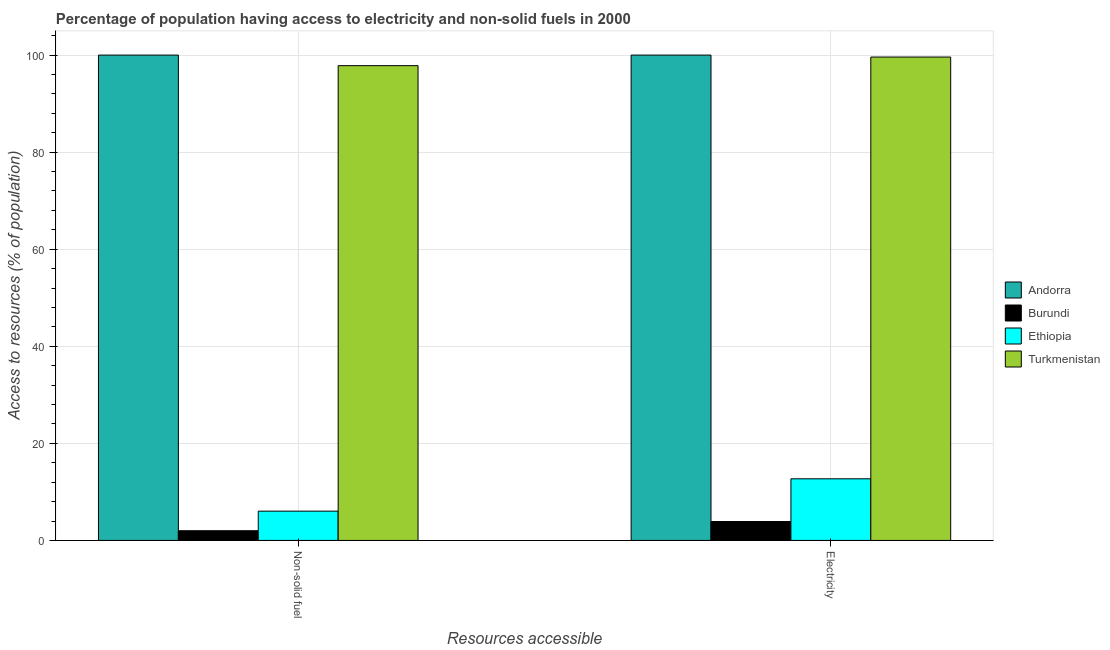Are the number of bars per tick equal to the number of legend labels?
Your response must be concise. Yes. How many bars are there on the 1st tick from the left?
Provide a succinct answer. 4. How many bars are there on the 2nd tick from the right?
Provide a short and direct response. 4. What is the label of the 1st group of bars from the left?
Your answer should be compact. Non-solid fuel. What is the percentage of population having access to electricity in Burundi?
Your answer should be compact. 3.9. Across all countries, what is the minimum percentage of population having access to electricity?
Ensure brevity in your answer.  3.9. In which country was the percentage of population having access to non-solid fuel maximum?
Provide a succinct answer. Andorra. In which country was the percentage of population having access to non-solid fuel minimum?
Provide a succinct answer. Burundi. What is the total percentage of population having access to electricity in the graph?
Provide a short and direct response. 216.2. What is the difference between the percentage of population having access to non-solid fuel in Burundi and that in Andorra?
Make the answer very short. -98. What is the difference between the percentage of population having access to electricity in Ethiopia and the percentage of population having access to non-solid fuel in Burundi?
Give a very brief answer. 10.7. What is the average percentage of population having access to non-solid fuel per country?
Your answer should be very brief. 51.46. What is the difference between the percentage of population having access to non-solid fuel and percentage of population having access to electricity in Burundi?
Give a very brief answer. -1.9. In how many countries, is the percentage of population having access to non-solid fuel greater than 68 %?
Ensure brevity in your answer.  2. What is the ratio of the percentage of population having access to non-solid fuel in Burundi to that in Turkmenistan?
Offer a terse response. 0.02. Is the percentage of population having access to non-solid fuel in Burundi less than that in Turkmenistan?
Offer a very short reply. Yes. In how many countries, is the percentage of population having access to non-solid fuel greater than the average percentage of population having access to non-solid fuel taken over all countries?
Offer a very short reply. 2. What does the 1st bar from the left in Electricity represents?
Offer a terse response. Andorra. What does the 1st bar from the right in Electricity represents?
Keep it short and to the point. Turkmenistan. How many countries are there in the graph?
Your response must be concise. 4. Are the values on the major ticks of Y-axis written in scientific E-notation?
Ensure brevity in your answer.  No. Does the graph contain any zero values?
Give a very brief answer. No. Where does the legend appear in the graph?
Your answer should be very brief. Center right. How are the legend labels stacked?
Offer a very short reply. Vertical. What is the title of the graph?
Offer a very short reply. Percentage of population having access to electricity and non-solid fuels in 2000. What is the label or title of the X-axis?
Keep it short and to the point. Resources accessible. What is the label or title of the Y-axis?
Make the answer very short. Access to resources (% of population). What is the Access to resources (% of population) of Burundi in Non-solid fuel?
Keep it short and to the point. 2. What is the Access to resources (% of population) of Ethiopia in Non-solid fuel?
Your answer should be compact. 6.04. What is the Access to resources (% of population) of Turkmenistan in Non-solid fuel?
Provide a succinct answer. 97.82. What is the Access to resources (% of population) of Burundi in Electricity?
Your answer should be compact. 3.9. What is the Access to resources (% of population) in Turkmenistan in Electricity?
Make the answer very short. 99.6. Across all Resources accessible, what is the maximum Access to resources (% of population) in Burundi?
Make the answer very short. 3.9. Across all Resources accessible, what is the maximum Access to resources (% of population) of Ethiopia?
Give a very brief answer. 12.7. Across all Resources accessible, what is the maximum Access to resources (% of population) of Turkmenistan?
Your answer should be compact. 99.6. Across all Resources accessible, what is the minimum Access to resources (% of population) of Andorra?
Your answer should be very brief. 100. Across all Resources accessible, what is the minimum Access to resources (% of population) of Burundi?
Keep it short and to the point. 2. Across all Resources accessible, what is the minimum Access to resources (% of population) in Ethiopia?
Provide a succinct answer. 6.04. Across all Resources accessible, what is the minimum Access to resources (% of population) of Turkmenistan?
Provide a short and direct response. 97.82. What is the total Access to resources (% of population) of Ethiopia in the graph?
Your response must be concise. 18.74. What is the total Access to resources (% of population) in Turkmenistan in the graph?
Ensure brevity in your answer.  197.42. What is the difference between the Access to resources (% of population) in Andorra in Non-solid fuel and that in Electricity?
Provide a short and direct response. 0. What is the difference between the Access to resources (% of population) in Ethiopia in Non-solid fuel and that in Electricity?
Give a very brief answer. -6.66. What is the difference between the Access to resources (% of population) in Turkmenistan in Non-solid fuel and that in Electricity?
Your answer should be compact. -1.78. What is the difference between the Access to resources (% of population) in Andorra in Non-solid fuel and the Access to resources (% of population) in Burundi in Electricity?
Offer a very short reply. 96.1. What is the difference between the Access to resources (% of population) in Andorra in Non-solid fuel and the Access to resources (% of population) in Ethiopia in Electricity?
Provide a succinct answer. 87.3. What is the difference between the Access to resources (% of population) of Burundi in Non-solid fuel and the Access to resources (% of population) of Ethiopia in Electricity?
Your response must be concise. -10.7. What is the difference between the Access to resources (% of population) of Burundi in Non-solid fuel and the Access to resources (% of population) of Turkmenistan in Electricity?
Make the answer very short. -97.6. What is the difference between the Access to resources (% of population) in Ethiopia in Non-solid fuel and the Access to resources (% of population) in Turkmenistan in Electricity?
Make the answer very short. -93.56. What is the average Access to resources (% of population) of Burundi per Resources accessible?
Your answer should be very brief. 2.95. What is the average Access to resources (% of population) in Ethiopia per Resources accessible?
Provide a short and direct response. 9.37. What is the average Access to resources (% of population) of Turkmenistan per Resources accessible?
Your response must be concise. 98.71. What is the difference between the Access to resources (% of population) of Andorra and Access to resources (% of population) of Burundi in Non-solid fuel?
Your answer should be very brief. 98. What is the difference between the Access to resources (% of population) of Andorra and Access to resources (% of population) of Ethiopia in Non-solid fuel?
Your response must be concise. 93.96. What is the difference between the Access to resources (% of population) in Andorra and Access to resources (% of population) in Turkmenistan in Non-solid fuel?
Keep it short and to the point. 2.18. What is the difference between the Access to resources (% of population) in Burundi and Access to resources (% of population) in Ethiopia in Non-solid fuel?
Give a very brief answer. -4.04. What is the difference between the Access to resources (% of population) in Burundi and Access to resources (% of population) in Turkmenistan in Non-solid fuel?
Your answer should be compact. -95.82. What is the difference between the Access to resources (% of population) of Ethiopia and Access to resources (% of population) of Turkmenistan in Non-solid fuel?
Keep it short and to the point. -91.79. What is the difference between the Access to resources (% of population) of Andorra and Access to resources (% of population) of Burundi in Electricity?
Your answer should be compact. 96.1. What is the difference between the Access to resources (% of population) in Andorra and Access to resources (% of population) in Ethiopia in Electricity?
Offer a very short reply. 87.3. What is the difference between the Access to resources (% of population) of Andorra and Access to resources (% of population) of Turkmenistan in Electricity?
Offer a terse response. 0.4. What is the difference between the Access to resources (% of population) in Burundi and Access to resources (% of population) in Turkmenistan in Electricity?
Your response must be concise. -95.7. What is the difference between the Access to resources (% of population) in Ethiopia and Access to resources (% of population) in Turkmenistan in Electricity?
Your answer should be very brief. -86.9. What is the ratio of the Access to resources (% of population) of Burundi in Non-solid fuel to that in Electricity?
Your answer should be very brief. 0.51. What is the ratio of the Access to resources (% of population) in Ethiopia in Non-solid fuel to that in Electricity?
Give a very brief answer. 0.48. What is the ratio of the Access to resources (% of population) of Turkmenistan in Non-solid fuel to that in Electricity?
Give a very brief answer. 0.98. What is the difference between the highest and the second highest Access to resources (% of population) in Andorra?
Make the answer very short. 0. What is the difference between the highest and the second highest Access to resources (% of population) of Ethiopia?
Your answer should be very brief. 6.66. What is the difference between the highest and the second highest Access to resources (% of population) in Turkmenistan?
Provide a short and direct response. 1.78. What is the difference between the highest and the lowest Access to resources (% of population) in Burundi?
Provide a succinct answer. 1.9. What is the difference between the highest and the lowest Access to resources (% of population) of Ethiopia?
Offer a very short reply. 6.66. What is the difference between the highest and the lowest Access to resources (% of population) of Turkmenistan?
Ensure brevity in your answer.  1.78. 